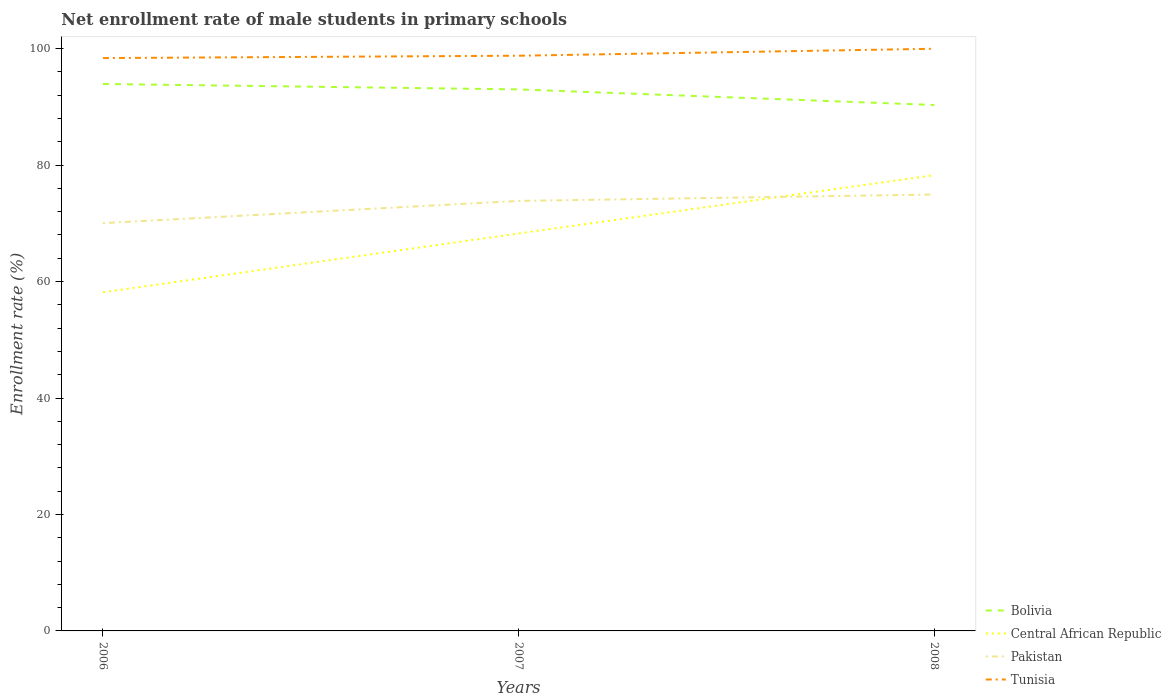How many different coloured lines are there?
Your answer should be very brief. 4. Is the number of lines equal to the number of legend labels?
Make the answer very short. Yes. Across all years, what is the maximum net enrollment rate of male students in primary schools in Tunisia?
Your answer should be compact. 98.39. In which year was the net enrollment rate of male students in primary schools in Central African Republic maximum?
Offer a very short reply. 2006. What is the total net enrollment rate of male students in primary schools in Bolivia in the graph?
Offer a terse response. 3.61. What is the difference between the highest and the second highest net enrollment rate of male students in primary schools in Central African Republic?
Give a very brief answer. 20.11. What is the difference between the highest and the lowest net enrollment rate of male students in primary schools in Central African Republic?
Your answer should be compact. 2. Does the graph contain any zero values?
Offer a terse response. No. Where does the legend appear in the graph?
Provide a succinct answer. Bottom right. How many legend labels are there?
Make the answer very short. 4. How are the legend labels stacked?
Ensure brevity in your answer.  Vertical. What is the title of the graph?
Offer a terse response. Net enrollment rate of male students in primary schools. Does "Gabon" appear as one of the legend labels in the graph?
Your answer should be compact. No. What is the label or title of the Y-axis?
Offer a very short reply. Enrollment rate (%). What is the Enrollment rate (%) in Bolivia in 2006?
Offer a very short reply. 93.94. What is the Enrollment rate (%) in Central African Republic in 2006?
Ensure brevity in your answer.  58.16. What is the Enrollment rate (%) of Pakistan in 2006?
Make the answer very short. 70.04. What is the Enrollment rate (%) of Tunisia in 2006?
Offer a terse response. 98.39. What is the Enrollment rate (%) of Bolivia in 2007?
Offer a very short reply. 93.01. What is the Enrollment rate (%) in Central African Republic in 2007?
Provide a succinct answer. 68.26. What is the Enrollment rate (%) of Pakistan in 2007?
Your answer should be very brief. 73.85. What is the Enrollment rate (%) in Tunisia in 2007?
Offer a terse response. 98.79. What is the Enrollment rate (%) of Bolivia in 2008?
Offer a terse response. 90.33. What is the Enrollment rate (%) of Central African Republic in 2008?
Give a very brief answer. 78.28. What is the Enrollment rate (%) of Pakistan in 2008?
Your answer should be very brief. 74.95. What is the Enrollment rate (%) of Tunisia in 2008?
Offer a terse response. 99.99. Across all years, what is the maximum Enrollment rate (%) of Bolivia?
Offer a terse response. 93.94. Across all years, what is the maximum Enrollment rate (%) of Central African Republic?
Offer a terse response. 78.28. Across all years, what is the maximum Enrollment rate (%) of Pakistan?
Offer a very short reply. 74.95. Across all years, what is the maximum Enrollment rate (%) in Tunisia?
Ensure brevity in your answer.  99.99. Across all years, what is the minimum Enrollment rate (%) of Bolivia?
Your answer should be compact. 90.33. Across all years, what is the minimum Enrollment rate (%) of Central African Republic?
Offer a terse response. 58.16. Across all years, what is the minimum Enrollment rate (%) of Pakistan?
Make the answer very short. 70.04. Across all years, what is the minimum Enrollment rate (%) in Tunisia?
Offer a terse response. 98.39. What is the total Enrollment rate (%) in Bolivia in the graph?
Offer a very short reply. 277.27. What is the total Enrollment rate (%) of Central African Republic in the graph?
Give a very brief answer. 204.7. What is the total Enrollment rate (%) in Pakistan in the graph?
Your response must be concise. 218.84. What is the total Enrollment rate (%) in Tunisia in the graph?
Keep it short and to the point. 297.17. What is the difference between the Enrollment rate (%) in Bolivia in 2006 and that in 2007?
Offer a very short reply. 0.93. What is the difference between the Enrollment rate (%) in Central African Republic in 2006 and that in 2007?
Provide a succinct answer. -10.1. What is the difference between the Enrollment rate (%) of Pakistan in 2006 and that in 2007?
Make the answer very short. -3.81. What is the difference between the Enrollment rate (%) of Tunisia in 2006 and that in 2007?
Offer a terse response. -0.4. What is the difference between the Enrollment rate (%) in Bolivia in 2006 and that in 2008?
Your response must be concise. 3.61. What is the difference between the Enrollment rate (%) in Central African Republic in 2006 and that in 2008?
Give a very brief answer. -20.11. What is the difference between the Enrollment rate (%) of Pakistan in 2006 and that in 2008?
Provide a succinct answer. -4.91. What is the difference between the Enrollment rate (%) of Tunisia in 2006 and that in 2008?
Your answer should be compact. -1.6. What is the difference between the Enrollment rate (%) in Bolivia in 2007 and that in 2008?
Give a very brief answer. 2.68. What is the difference between the Enrollment rate (%) of Central African Republic in 2007 and that in 2008?
Make the answer very short. -10.02. What is the difference between the Enrollment rate (%) of Pakistan in 2007 and that in 2008?
Give a very brief answer. -1.1. What is the difference between the Enrollment rate (%) in Tunisia in 2007 and that in 2008?
Your answer should be compact. -1.2. What is the difference between the Enrollment rate (%) in Bolivia in 2006 and the Enrollment rate (%) in Central African Republic in 2007?
Your answer should be very brief. 25.67. What is the difference between the Enrollment rate (%) in Bolivia in 2006 and the Enrollment rate (%) in Pakistan in 2007?
Keep it short and to the point. 20.08. What is the difference between the Enrollment rate (%) of Bolivia in 2006 and the Enrollment rate (%) of Tunisia in 2007?
Ensure brevity in your answer.  -4.86. What is the difference between the Enrollment rate (%) of Central African Republic in 2006 and the Enrollment rate (%) of Pakistan in 2007?
Offer a very short reply. -15.69. What is the difference between the Enrollment rate (%) of Central African Republic in 2006 and the Enrollment rate (%) of Tunisia in 2007?
Give a very brief answer. -40.63. What is the difference between the Enrollment rate (%) in Pakistan in 2006 and the Enrollment rate (%) in Tunisia in 2007?
Make the answer very short. -28.75. What is the difference between the Enrollment rate (%) of Bolivia in 2006 and the Enrollment rate (%) of Central African Republic in 2008?
Give a very brief answer. 15.66. What is the difference between the Enrollment rate (%) in Bolivia in 2006 and the Enrollment rate (%) in Pakistan in 2008?
Keep it short and to the point. 18.98. What is the difference between the Enrollment rate (%) of Bolivia in 2006 and the Enrollment rate (%) of Tunisia in 2008?
Offer a very short reply. -6.05. What is the difference between the Enrollment rate (%) of Central African Republic in 2006 and the Enrollment rate (%) of Pakistan in 2008?
Keep it short and to the point. -16.79. What is the difference between the Enrollment rate (%) of Central African Republic in 2006 and the Enrollment rate (%) of Tunisia in 2008?
Give a very brief answer. -41.82. What is the difference between the Enrollment rate (%) in Pakistan in 2006 and the Enrollment rate (%) in Tunisia in 2008?
Your response must be concise. -29.95. What is the difference between the Enrollment rate (%) in Bolivia in 2007 and the Enrollment rate (%) in Central African Republic in 2008?
Offer a terse response. 14.73. What is the difference between the Enrollment rate (%) of Bolivia in 2007 and the Enrollment rate (%) of Pakistan in 2008?
Ensure brevity in your answer.  18.05. What is the difference between the Enrollment rate (%) in Bolivia in 2007 and the Enrollment rate (%) in Tunisia in 2008?
Your answer should be very brief. -6.98. What is the difference between the Enrollment rate (%) in Central African Republic in 2007 and the Enrollment rate (%) in Pakistan in 2008?
Ensure brevity in your answer.  -6.69. What is the difference between the Enrollment rate (%) of Central African Republic in 2007 and the Enrollment rate (%) of Tunisia in 2008?
Your response must be concise. -31.72. What is the difference between the Enrollment rate (%) in Pakistan in 2007 and the Enrollment rate (%) in Tunisia in 2008?
Ensure brevity in your answer.  -26.14. What is the average Enrollment rate (%) in Bolivia per year?
Offer a terse response. 92.42. What is the average Enrollment rate (%) of Central African Republic per year?
Make the answer very short. 68.23. What is the average Enrollment rate (%) in Pakistan per year?
Your answer should be very brief. 72.95. What is the average Enrollment rate (%) of Tunisia per year?
Your response must be concise. 99.06. In the year 2006, what is the difference between the Enrollment rate (%) of Bolivia and Enrollment rate (%) of Central African Republic?
Provide a short and direct response. 35.77. In the year 2006, what is the difference between the Enrollment rate (%) in Bolivia and Enrollment rate (%) in Pakistan?
Provide a succinct answer. 23.89. In the year 2006, what is the difference between the Enrollment rate (%) in Bolivia and Enrollment rate (%) in Tunisia?
Make the answer very short. -4.45. In the year 2006, what is the difference between the Enrollment rate (%) of Central African Republic and Enrollment rate (%) of Pakistan?
Keep it short and to the point. -11.88. In the year 2006, what is the difference between the Enrollment rate (%) in Central African Republic and Enrollment rate (%) in Tunisia?
Ensure brevity in your answer.  -40.22. In the year 2006, what is the difference between the Enrollment rate (%) in Pakistan and Enrollment rate (%) in Tunisia?
Your response must be concise. -28.35. In the year 2007, what is the difference between the Enrollment rate (%) of Bolivia and Enrollment rate (%) of Central African Republic?
Ensure brevity in your answer.  24.74. In the year 2007, what is the difference between the Enrollment rate (%) of Bolivia and Enrollment rate (%) of Pakistan?
Offer a very short reply. 19.15. In the year 2007, what is the difference between the Enrollment rate (%) of Bolivia and Enrollment rate (%) of Tunisia?
Offer a very short reply. -5.79. In the year 2007, what is the difference between the Enrollment rate (%) of Central African Republic and Enrollment rate (%) of Pakistan?
Ensure brevity in your answer.  -5.59. In the year 2007, what is the difference between the Enrollment rate (%) of Central African Republic and Enrollment rate (%) of Tunisia?
Your answer should be compact. -30.53. In the year 2007, what is the difference between the Enrollment rate (%) of Pakistan and Enrollment rate (%) of Tunisia?
Offer a terse response. -24.94. In the year 2008, what is the difference between the Enrollment rate (%) of Bolivia and Enrollment rate (%) of Central African Republic?
Your response must be concise. 12.05. In the year 2008, what is the difference between the Enrollment rate (%) of Bolivia and Enrollment rate (%) of Pakistan?
Offer a terse response. 15.37. In the year 2008, what is the difference between the Enrollment rate (%) of Bolivia and Enrollment rate (%) of Tunisia?
Your answer should be very brief. -9.66. In the year 2008, what is the difference between the Enrollment rate (%) in Central African Republic and Enrollment rate (%) in Pakistan?
Provide a short and direct response. 3.33. In the year 2008, what is the difference between the Enrollment rate (%) of Central African Republic and Enrollment rate (%) of Tunisia?
Ensure brevity in your answer.  -21.71. In the year 2008, what is the difference between the Enrollment rate (%) of Pakistan and Enrollment rate (%) of Tunisia?
Keep it short and to the point. -25.04. What is the ratio of the Enrollment rate (%) in Bolivia in 2006 to that in 2007?
Ensure brevity in your answer.  1.01. What is the ratio of the Enrollment rate (%) of Central African Republic in 2006 to that in 2007?
Your response must be concise. 0.85. What is the ratio of the Enrollment rate (%) in Pakistan in 2006 to that in 2007?
Your answer should be compact. 0.95. What is the ratio of the Enrollment rate (%) in Tunisia in 2006 to that in 2007?
Ensure brevity in your answer.  1. What is the ratio of the Enrollment rate (%) in Central African Republic in 2006 to that in 2008?
Keep it short and to the point. 0.74. What is the ratio of the Enrollment rate (%) of Pakistan in 2006 to that in 2008?
Your response must be concise. 0.93. What is the ratio of the Enrollment rate (%) in Bolivia in 2007 to that in 2008?
Offer a very short reply. 1.03. What is the ratio of the Enrollment rate (%) in Central African Republic in 2007 to that in 2008?
Your answer should be very brief. 0.87. What is the ratio of the Enrollment rate (%) in Pakistan in 2007 to that in 2008?
Your answer should be very brief. 0.99. What is the ratio of the Enrollment rate (%) in Tunisia in 2007 to that in 2008?
Your answer should be compact. 0.99. What is the difference between the highest and the second highest Enrollment rate (%) of Bolivia?
Offer a terse response. 0.93. What is the difference between the highest and the second highest Enrollment rate (%) of Central African Republic?
Provide a short and direct response. 10.02. What is the difference between the highest and the second highest Enrollment rate (%) in Pakistan?
Ensure brevity in your answer.  1.1. What is the difference between the highest and the second highest Enrollment rate (%) in Tunisia?
Provide a succinct answer. 1.2. What is the difference between the highest and the lowest Enrollment rate (%) of Bolivia?
Provide a short and direct response. 3.61. What is the difference between the highest and the lowest Enrollment rate (%) of Central African Republic?
Provide a succinct answer. 20.11. What is the difference between the highest and the lowest Enrollment rate (%) of Pakistan?
Offer a terse response. 4.91. What is the difference between the highest and the lowest Enrollment rate (%) in Tunisia?
Keep it short and to the point. 1.6. 